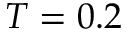<formula> <loc_0><loc_0><loc_500><loc_500>T = 0 . 2</formula> 